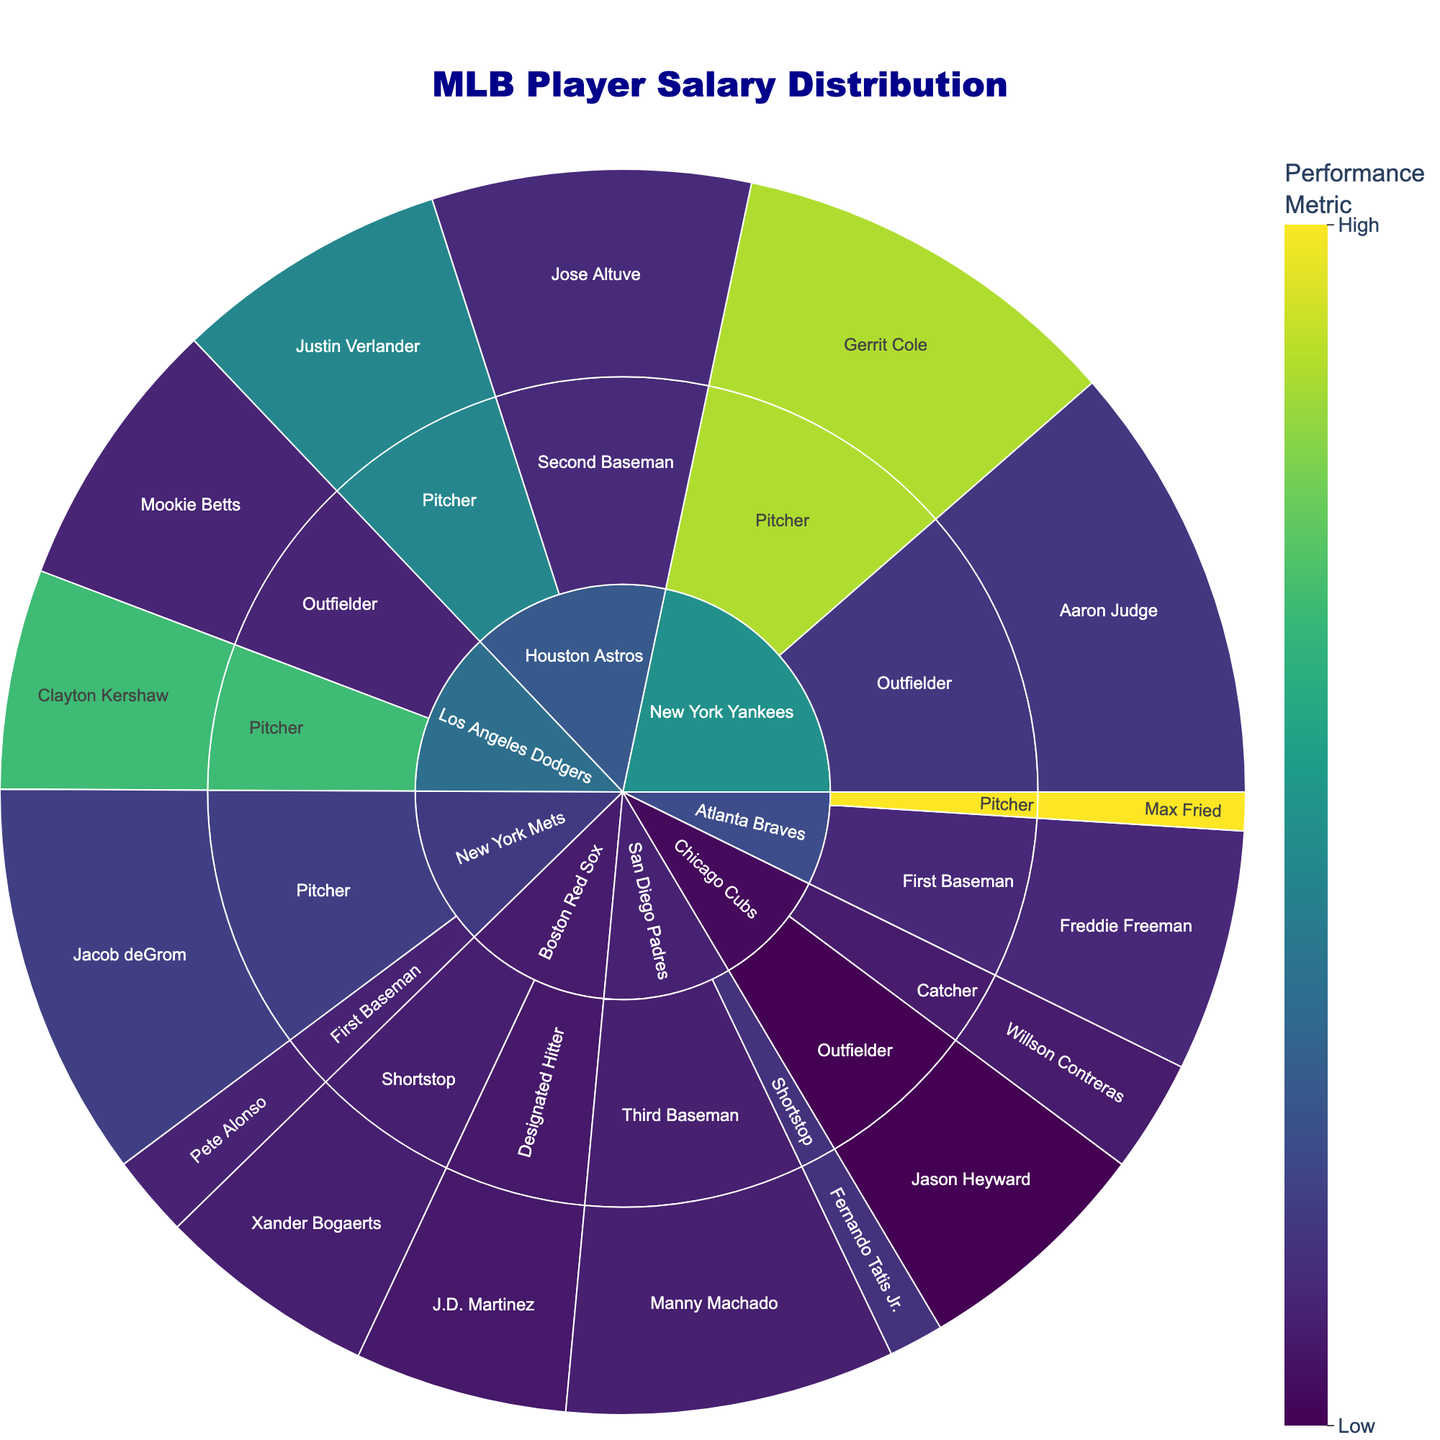What is the title of the figure? The title of the figure is typically displayed at the top and formatted to stand out. In this plot, it is specified in the 'title' field of the layout.
Answer: MLB Player Salary Distribution Which team has the highest total salary for all its players combined? By examining the sunburst plot's structure, observe the size of the sectors corresponding to each team. The team with the largest overall sector is the one with the highest total salary.
Answer: New York Yankees Which position has the highest salary within the Los Angeles Dodgers? Identify the Los Angeles Dodgers segment, then check the sub-segments representing different positions. The position with the largest slice has the highest salary.
Answer: Outfielder What is the salary of Gerrit Cole? Find the segment for the New York Yankees, then the sub-segment for Pitcher, and locate Gerrit Cole. The value associated with his name represents his salary.
Answer: $36,000,000 How does Aaron Judge's performance metric compare to Gerrit Cole's? Locate both players within the New York Yankees segment. Compare their performance metrics, which are color-coded and also visible on hover.
Answer: Aaron Judge: 1.019, Gerrit Cole: 2.75 What is the average performance metric for outfielders in this data? Identify all outfielders in the sunburst plot, then sum their performance metrics and divide by the number of outfielders. (Aaron Judge: 1.019, Mookie Betts: 0.873, Jason Heyward: 0.626) Avg = (1.019 + 0.873 + 0.626) / 3
Answer: 0.839 Which player in the Houston Astros has the highest performance metric? Find the Houston Astros segment, then check the sub-segments representing different players. Compare their performance metrics to identify the highest.
Answer: Justin Verlander What percentage of the total salary does Manny Machado's salary represent? Identify Manny Machado's salary, then sum all players' salaries. Divide Machado's salary by the total salary and multiply by 100. Total: $36M + $40M + $20M + $25M + $19.35M + $20M + $29M + $25M + $10.25M + $22M + $22M + $3.5M + $30M + $5M + $36M + $7.4M = $350.5M. Manny Machado's salary = $30M, percentage = ($30M / $350.5M) * 100
Answer: 8.56% What is the performance metric range represented by the color scale? The color scale represents a range of performance metrics from the minimum to the maximum performance values present in the dataset. By checking the color axis, the range is shown.
Answer: 0.626 - 3.04 